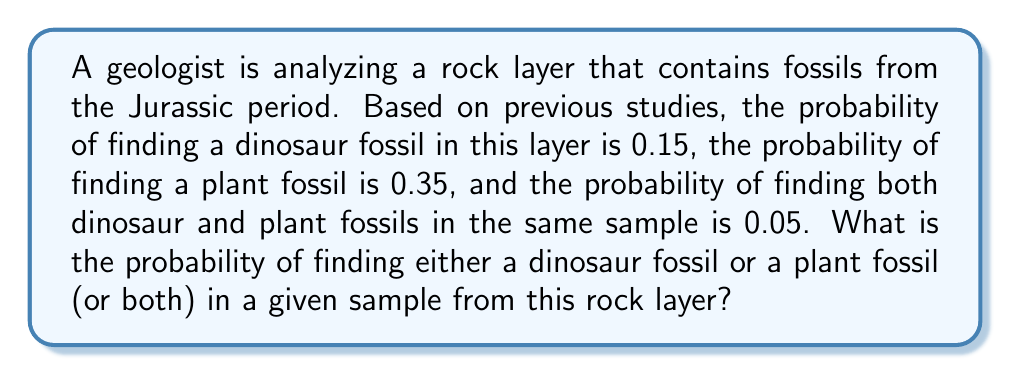What is the answer to this math problem? To solve this problem, we'll use the addition rule of probability. Let's define our events:

$A$ = finding a dinosaur fossil
$B$ = finding a plant fossil

We're given:
$P(A) = 0.15$
$P(B) = 0.35$
$P(A \cap B) = 0.05$

We want to find $P(A \cup B)$, which is the probability of finding either a dinosaur fossil or a plant fossil (or both).

The addition rule of probability states:

$$P(A \cup B) = P(A) + P(B) - P(A \cap B)$$

This rule accounts for the overlap between events A and B to avoid double-counting.

Substituting our known values:

$$P(A \cup B) = 0.15 + 0.35 - 0.05$$

$$P(A \cup B) = 0.50 - 0.05 = 0.45$$

Therefore, the probability of finding either a dinosaur fossil or a plant fossil (or both) in a given sample from this rock layer is 0.45 or 45%.
Answer: 0.45 or 45% 